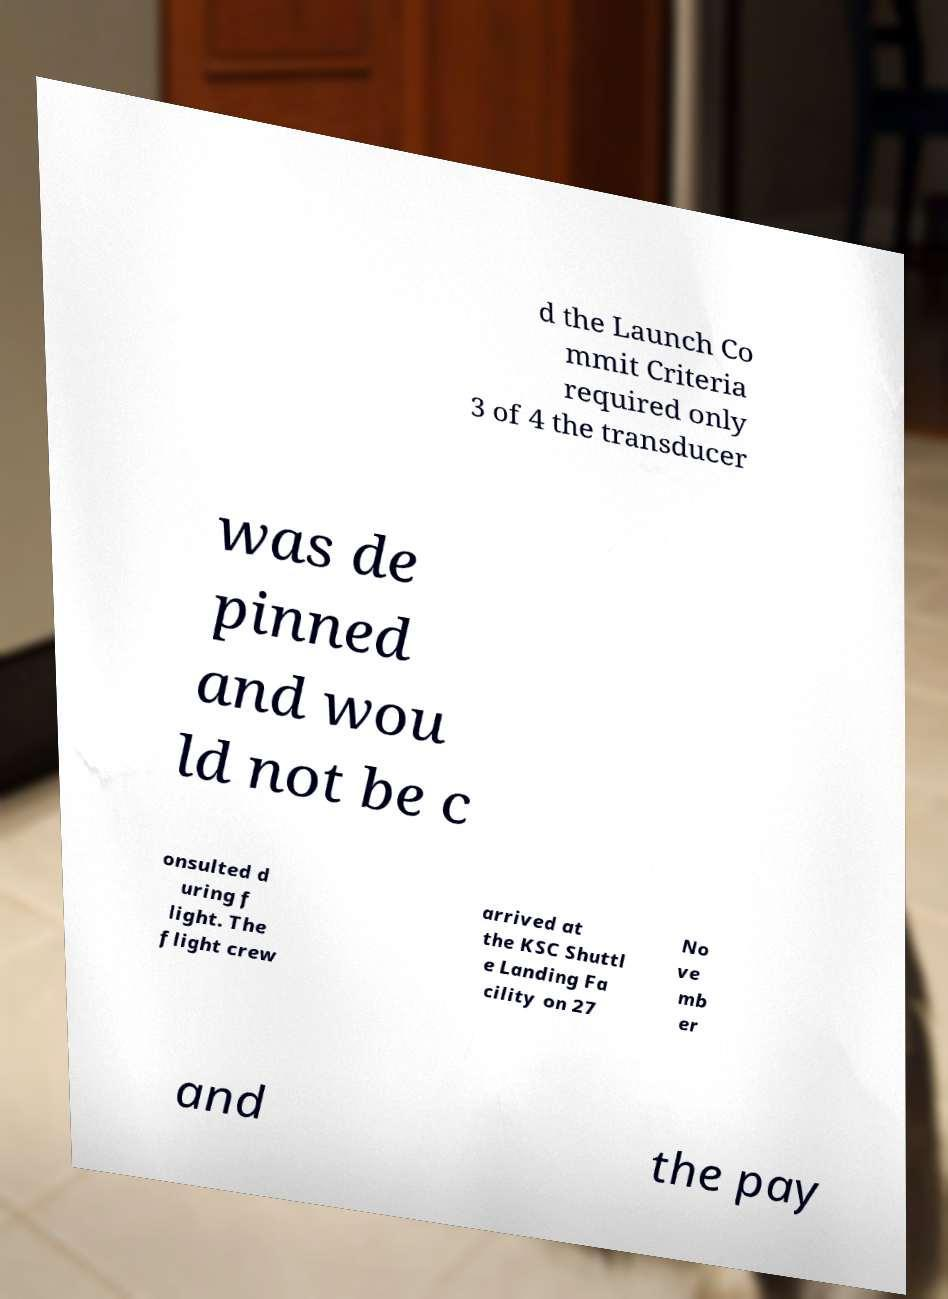Could you extract and type out the text from this image? d the Launch Co mmit Criteria required only 3 of 4 the transducer was de pinned and wou ld not be c onsulted d uring f light. The flight crew arrived at the KSC Shuttl e Landing Fa cility on 27 No ve mb er and the pay 